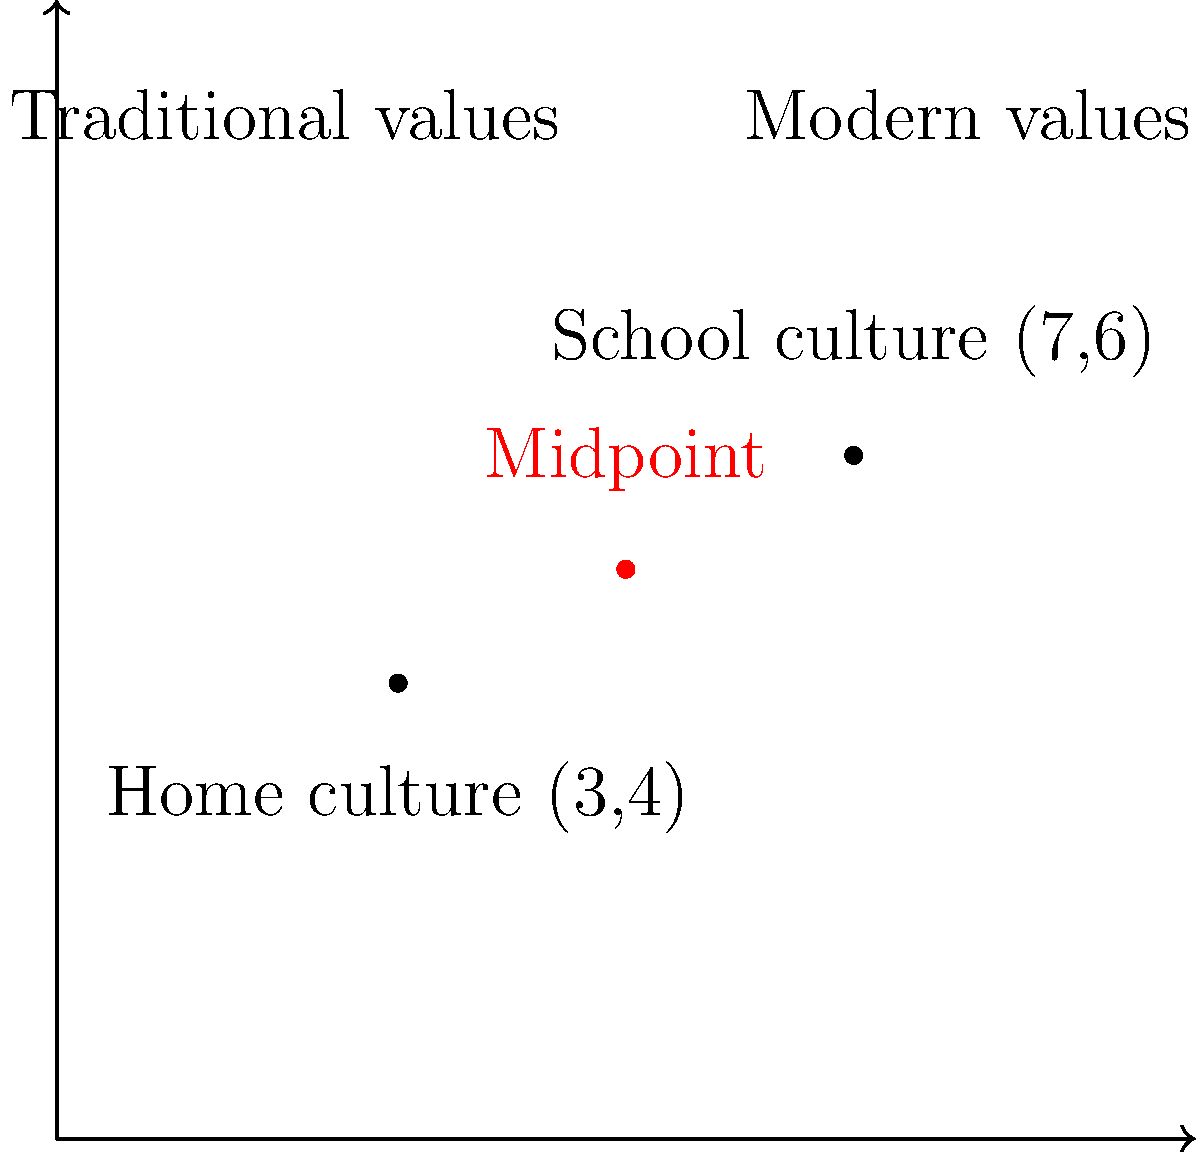In a coordinate system, your home culture's values are represented by the point (3,4), while the values prevalent in your school culture are represented by the point (7,6). To find a balance between these two cultural perspectives, you decide to calculate the midpoint. What are the coordinates of this midpoint? To find the midpoint between two points, we use the midpoint formula:

$$ \text{Midpoint} = \left(\frac{x_1 + x_2}{2}, \frac{y_1 + y_2}{2}\right) $$

Where $(x_1, y_1)$ is the first point and $(x_2, y_2)$ is the second point.

Let's apply this formula to our situation:

1. Home culture point: $(x_1, y_1) = (3, 4)$
2. School culture point: $(x_2, y_2) = (7, 6)$

Now, let's calculate:

$$ x \text{ coordinate} = \frac{x_1 + x_2}{2} = \frac{3 + 7}{2} = \frac{10}{2} = 5 $$

$$ y \text{ coordinate} = \frac{y_1 + y_2}{2} = \frac{4 + 6}{2} = \frac{10}{2} = 5 $$

Therefore, the midpoint coordinates are (5, 5).
Answer: (5, 5) 